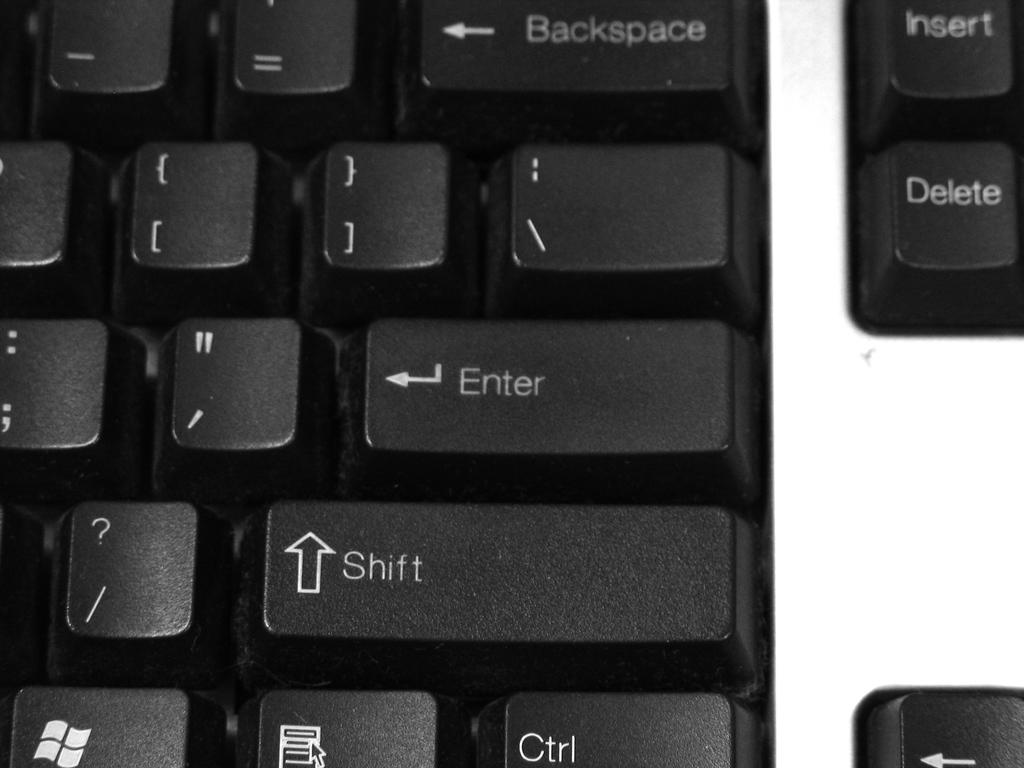<image>
Describe the image concisely. a key on a keyboard that says shift 